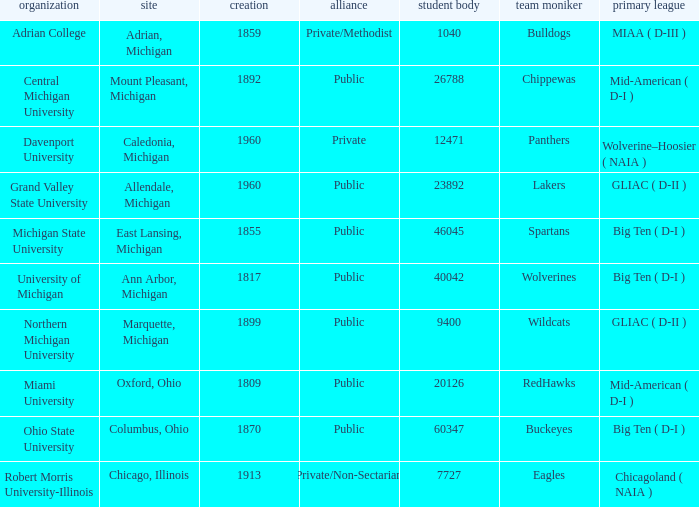What is the location of robert morris university-illinois? Chicago, Illinois. 